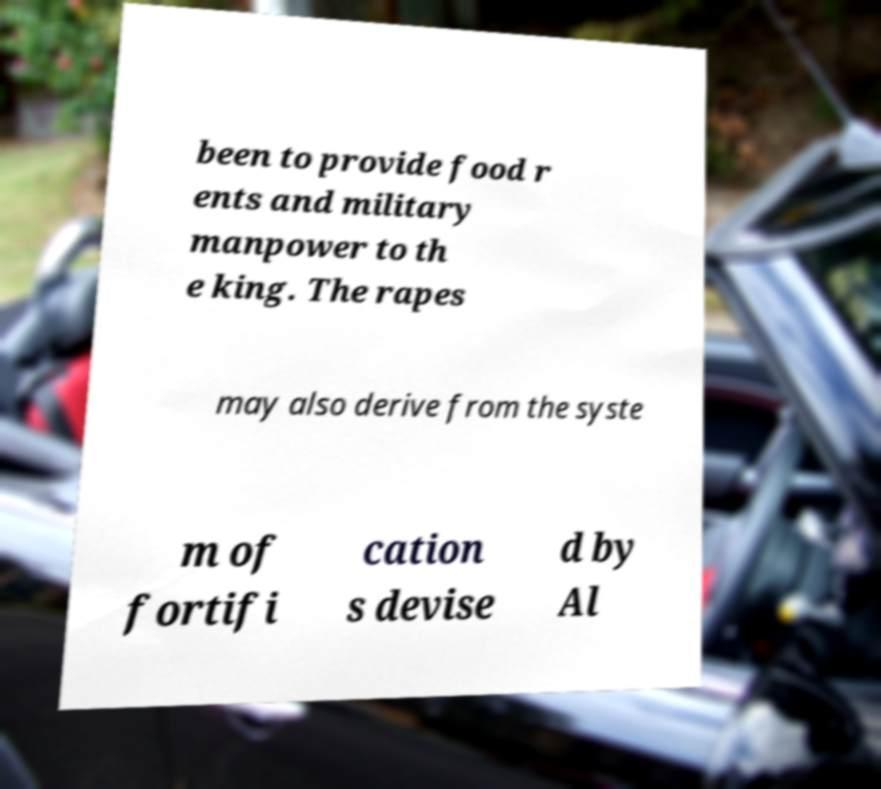Can you accurately transcribe the text from the provided image for me? been to provide food r ents and military manpower to th e king. The rapes may also derive from the syste m of fortifi cation s devise d by Al 